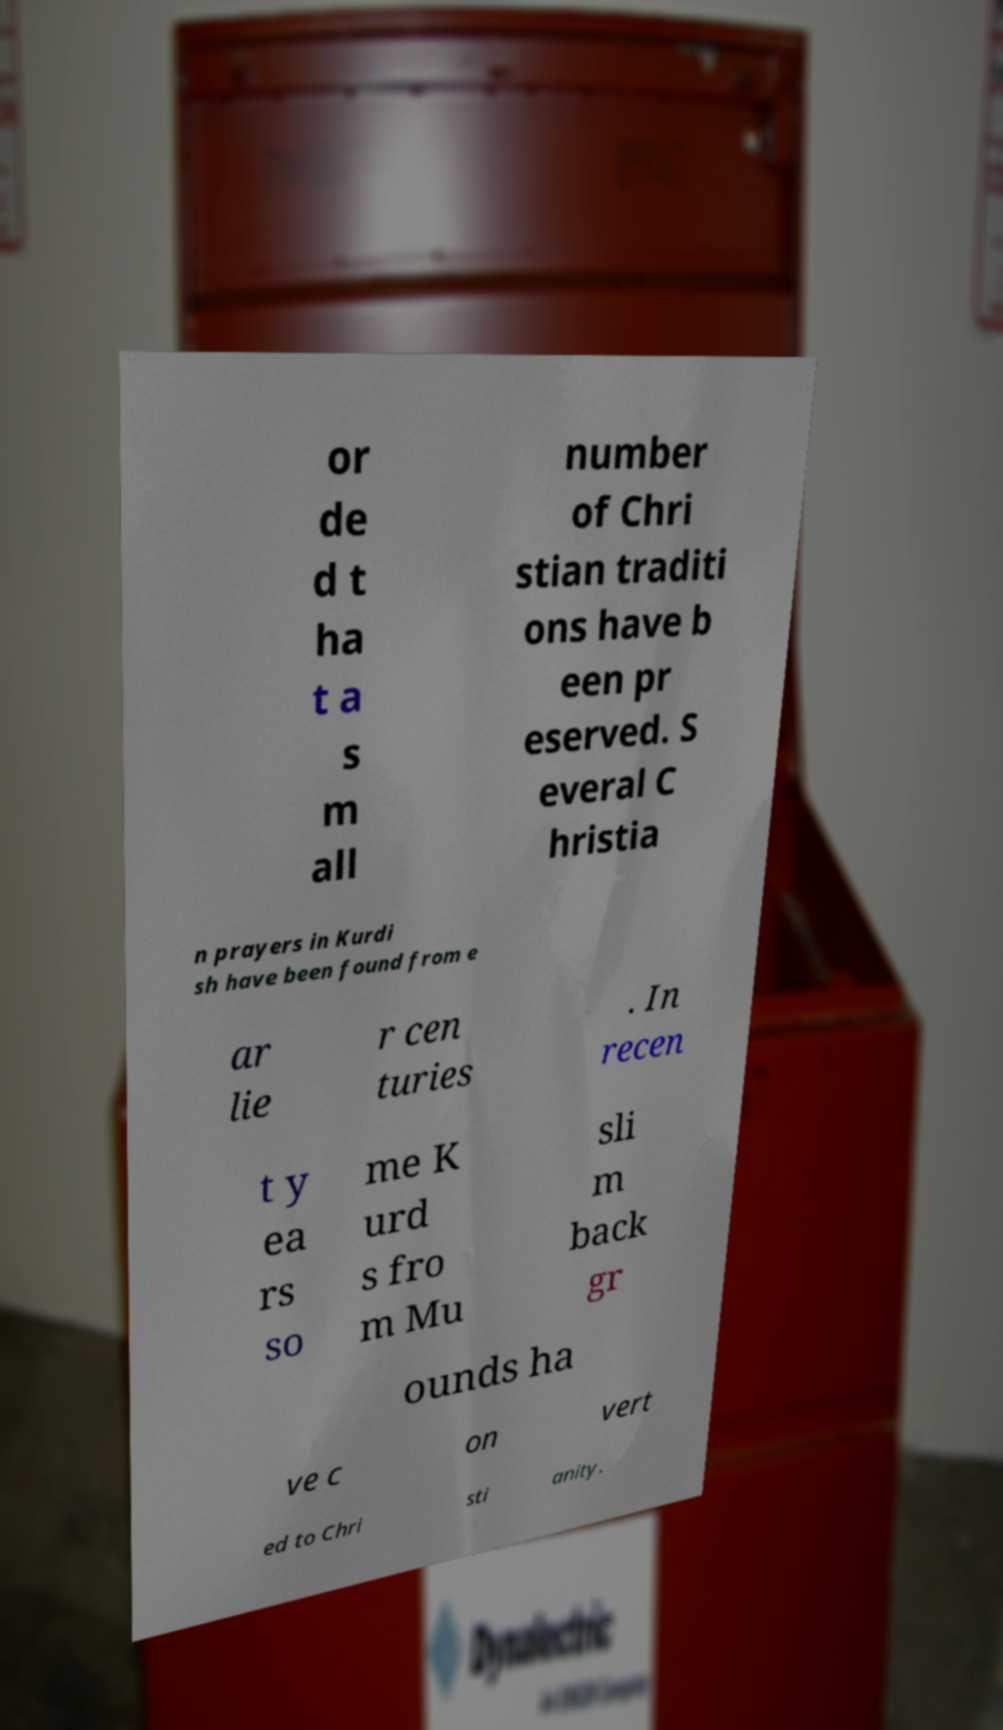Can you accurately transcribe the text from the provided image for me? or de d t ha t a s m all number of Chri stian traditi ons have b een pr eserved. S everal C hristia n prayers in Kurdi sh have been found from e ar lie r cen turies . In recen t y ea rs so me K urd s fro m Mu sli m back gr ounds ha ve c on vert ed to Chri sti anity. 